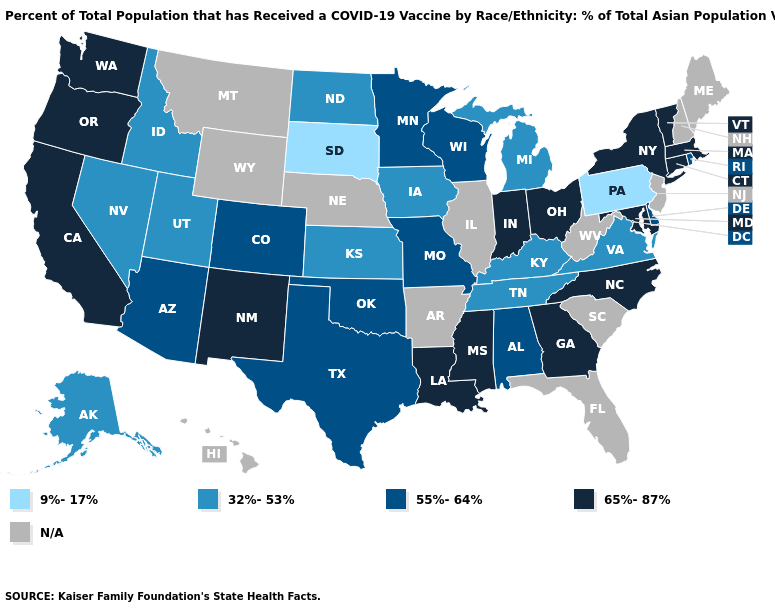Does Massachusetts have the highest value in the Northeast?
Give a very brief answer. Yes. What is the lowest value in states that border Iowa?
Write a very short answer. 9%-17%. Does the first symbol in the legend represent the smallest category?
Keep it brief. Yes. What is the highest value in the USA?
Give a very brief answer. 65%-87%. How many symbols are there in the legend?
Answer briefly. 5. What is the value of Arizona?
Answer briefly. 55%-64%. Among the states that border Kansas , which have the highest value?
Write a very short answer. Colorado, Missouri, Oklahoma. Which states hav the highest value in the West?
Be succinct. California, New Mexico, Oregon, Washington. Does the first symbol in the legend represent the smallest category?
Give a very brief answer. Yes. What is the highest value in the USA?
Write a very short answer. 65%-87%. Name the states that have a value in the range 65%-87%?
Keep it brief. California, Connecticut, Georgia, Indiana, Louisiana, Maryland, Massachusetts, Mississippi, New Mexico, New York, North Carolina, Ohio, Oregon, Vermont, Washington. Does Tennessee have the highest value in the USA?
Keep it brief. No. Which states hav the highest value in the South?
Quick response, please. Georgia, Louisiana, Maryland, Mississippi, North Carolina. Does Indiana have the highest value in the MidWest?
Keep it brief. Yes. 